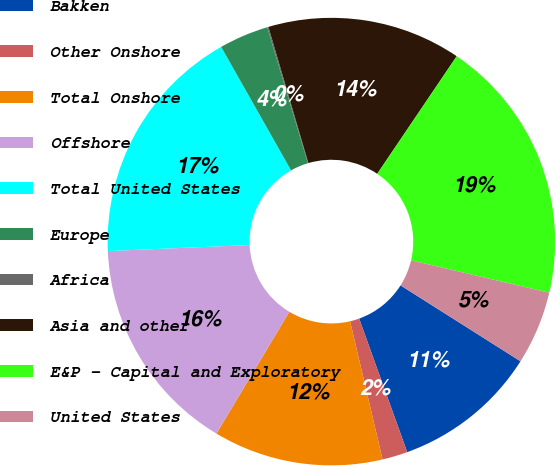<chart> <loc_0><loc_0><loc_500><loc_500><pie_chart><fcel>Bakken<fcel>Other Onshore<fcel>Total Onshore<fcel>Offshore<fcel>Total United States<fcel>Europe<fcel>Africa<fcel>Asia and other<fcel>E&P - Capital and Exploratory<fcel>United States<nl><fcel>10.52%<fcel>1.83%<fcel>12.26%<fcel>15.74%<fcel>17.47%<fcel>3.57%<fcel>0.09%<fcel>14.0%<fcel>19.21%<fcel>5.31%<nl></chart> 